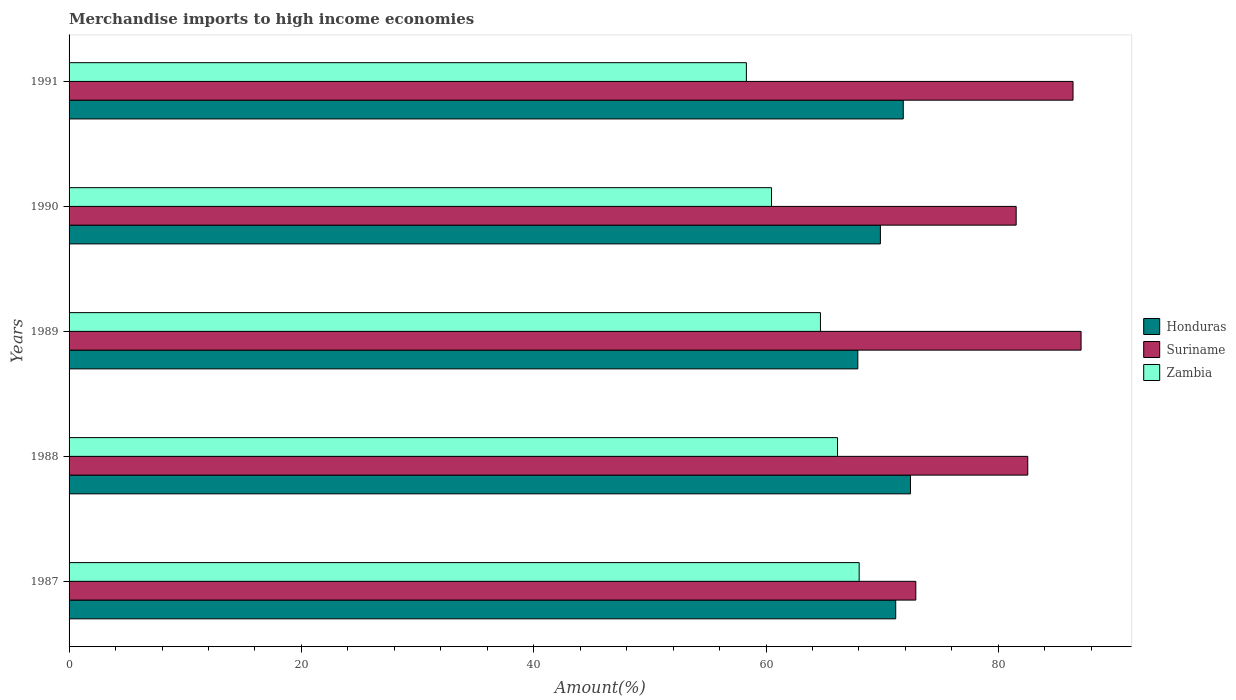How many groups of bars are there?
Keep it short and to the point. 5. How many bars are there on the 2nd tick from the bottom?
Provide a short and direct response. 3. In how many cases, is the number of bars for a given year not equal to the number of legend labels?
Your answer should be compact. 0. What is the percentage of amount earned from merchandise imports in Suriname in 1987?
Your answer should be very brief. 72.89. Across all years, what is the maximum percentage of amount earned from merchandise imports in Suriname?
Ensure brevity in your answer.  87.12. Across all years, what is the minimum percentage of amount earned from merchandise imports in Zambia?
Ensure brevity in your answer.  58.31. What is the total percentage of amount earned from merchandise imports in Honduras in the graph?
Provide a short and direct response. 353.15. What is the difference between the percentage of amount earned from merchandise imports in Zambia in 1989 and that in 1990?
Offer a very short reply. 4.21. What is the difference between the percentage of amount earned from merchandise imports in Honduras in 1988 and the percentage of amount earned from merchandise imports in Suriname in 1989?
Your answer should be very brief. -14.69. What is the average percentage of amount earned from merchandise imports in Honduras per year?
Your answer should be compact. 70.63. In the year 1988, what is the difference between the percentage of amount earned from merchandise imports in Zambia and percentage of amount earned from merchandise imports in Suriname?
Ensure brevity in your answer.  -16.38. What is the ratio of the percentage of amount earned from merchandise imports in Honduras in 1987 to that in 1990?
Keep it short and to the point. 1.02. What is the difference between the highest and the second highest percentage of amount earned from merchandise imports in Suriname?
Provide a succinct answer. 0.69. What is the difference between the highest and the lowest percentage of amount earned from merchandise imports in Zambia?
Provide a short and direct response. 9.71. In how many years, is the percentage of amount earned from merchandise imports in Honduras greater than the average percentage of amount earned from merchandise imports in Honduras taken over all years?
Keep it short and to the point. 3. Is the sum of the percentage of amount earned from merchandise imports in Honduras in 1988 and 1989 greater than the maximum percentage of amount earned from merchandise imports in Zambia across all years?
Offer a terse response. Yes. What does the 3rd bar from the top in 1989 represents?
Offer a very short reply. Honduras. What does the 1st bar from the bottom in 1988 represents?
Your answer should be very brief. Honduras. How many bars are there?
Provide a short and direct response. 15. What is the difference between two consecutive major ticks on the X-axis?
Keep it short and to the point. 20. Does the graph contain grids?
Give a very brief answer. No. Where does the legend appear in the graph?
Offer a terse response. Center right. What is the title of the graph?
Give a very brief answer. Merchandise imports to high income economies. What is the label or title of the X-axis?
Your response must be concise. Amount(%). What is the label or title of the Y-axis?
Give a very brief answer. Years. What is the Amount(%) of Honduras in 1987?
Offer a very short reply. 71.16. What is the Amount(%) of Suriname in 1987?
Your response must be concise. 72.89. What is the Amount(%) of Zambia in 1987?
Provide a succinct answer. 68.02. What is the Amount(%) of Honduras in 1988?
Keep it short and to the point. 72.43. What is the Amount(%) in Suriname in 1988?
Your answer should be compact. 82.53. What is the Amount(%) of Zambia in 1988?
Make the answer very short. 66.15. What is the Amount(%) of Honduras in 1989?
Your answer should be compact. 67.9. What is the Amount(%) of Suriname in 1989?
Your response must be concise. 87.12. What is the Amount(%) in Zambia in 1989?
Ensure brevity in your answer.  64.68. What is the Amount(%) in Honduras in 1990?
Make the answer very short. 69.84. What is the Amount(%) in Suriname in 1990?
Make the answer very short. 81.53. What is the Amount(%) of Zambia in 1990?
Keep it short and to the point. 60.47. What is the Amount(%) of Honduras in 1991?
Make the answer very short. 71.81. What is the Amount(%) of Suriname in 1991?
Ensure brevity in your answer.  86.43. What is the Amount(%) in Zambia in 1991?
Offer a terse response. 58.31. Across all years, what is the maximum Amount(%) of Honduras?
Make the answer very short. 72.43. Across all years, what is the maximum Amount(%) of Suriname?
Offer a very short reply. 87.12. Across all years, what is the maximum Amount(%) of Zambia?
Your answer should be compact. 68.02. Across all years, what is the minimum Amount(%) in Honduras?
Offer a very short reply. 67.9. Across all years, what is the minimum Amount(%) in Suriname?
Your answer should be very brief. 72.89. Across all years, what is the minimum Amount(%) in Zambia?
Your answer should be compact. 58.31. What is the total Amount(%) in Honduras in the graph?
Give a very brief answer. 353.15. What is the total Amount(%) of Suriname in the graph?
Offer a very short reply. 410.5. What is the total Amount(%) of Zambia in the graph?
Your answer should be very brief. 317.63. What is the difference between the Amount(%) of Honduras in 1987 and that in 1988?
Your answer should be compact. -1.27. What is the difference between the Amount(%) of Suriname in 1987 and that in 1988?
Keep it short and to the point. -9.64. What is the difference between the Amount(%) of Zambia in 1987 and that in 1988?
Make the answer very short. 1.86. What is the difference between the Amount(%) of Honduras in 1987 and that in 1989?
Give a very brief answer. 3.26. What is the difference between the Amount(%) in Suriname in 1987 and that in 1989?
Your response must be concise. -14.23. What is the difference between the Amount(%) of Zambia in 1987 and that in 1989?
Provide a succinct answer. 3.33. What is the difference between the Amount(%) of Honduras in 1987 and that in 1990?
Keep it short and to the point. 1.32. What is the difference between the Amount(%) in Suriname in 1987 and that in 1990?
Keep it short and to the point. -8.64. What is the difference between the Amount(%) in Zambia in 1987 and that in 1990?
Your answer should be compact. 7.54. What is the difference between the Amount(%) of Honduras in 1987 and that in 1991?
Give a very brief answer. -0.65. What is the difference between the Amount(%) in Suriname in 1987 and that in 1991?
Give a very brief answer. -13.53. What is the difference between the Amount(%) in Zambia in 1987 and that in 1991?
Ensure brevity in your answer.  9.71. What is the difference between the Amount(%) of Honduras in 1988 and that in 1989?
Provide a short and direct response. 4.53. What is the difference between the Amount(%) of Suriname in 1988 and that in 1989?
Keep it short and to the point. -4.59. What is the difference between the Amount(%) of Zambia in 1988 and that in 1989?
Give a very brief answer. 1.47. What is the difference between the Amount(%) in Honduras in 1988 and that in 1990?
Your answer should be very brief. 2.59. What is the difference between the Amount(%) in Zambia in 1988 and that in 1990?
Ensure brevity in your answer.  5.68. What is the difference between the Amount(%) of Honduras in 1988 and that in 1991?
Your answer should be compact. 0.62. What is the difference between the Amount(%) in Suriname in 1988 and that in 1991?
Your response must be concise. -3.9. What is the difference between the Amount(%) in Zambia in 1988 and that in 1991?
Make the answer very short. 7.85. What is the difference between the Amount(%) in Honduras in 1989 and that in 1990?
Your answer should be very brief. -1.94. What is the difference between the Amount(%) of Suriname in 1989 and that in 1990?
Offer a terse response. 5.59. What is the difference between the Amount(%) in Zambia in 1989 and that in 1990?
Give a very brief answer. 4.21. What is the difference between the Amount(%) of Honduras in 1989 and that in 1991?
Make the answer very short. -3.91. What is the difference between the Amount(%) in Suriname in 1989 and that in 1991?
Keep it short and to the point. 0.69. What is the difference between the Amount(%) of Zambia in 1989 and that in 1991?
Ensure brevity in your answer.  6.38. What is the difference between the Amount(%) of Honduras in 1990 and that in 1991?
Make the answer very short. -1.97. What is the difference between the Amount(%) of Suriname in 1990 and that in 1991?
Offer a terse response. -4.9. What is the difference between the Amount(%) in Zambia in 1990 and that in 1991?
Your answer should be very brief. 2.16. What is the difference between the Amount(%) of Honduras in 1987 and the Amount(%) of Suriname in 1988?
Ensure brevity in your answer.  -11.37. What is the difference between the Amount(%) in Honduras in 1987 and the Amount(%) in Zambia in 1988?
Keep it short and to the point. 5.01. What is the difference between the Amount(%) of Suriname in 1987 and the Amount(%) of Zambia in 1988?
Give a very brief answer. 6.74. What is the difference between the Amount(%) in Honduras in 1987 and the Amount(%) in Suriname in 1989?
Offer a terse response. -15.96. What is the difference between the Amount(%) in Honduras in 1987 and the Amount(%) in Zambia in 1989?
Keep it short and to the point. 6.48. What is the difference between the Amount(%) of Suriname in 1987 and the Amount(%) of Zambia in 1989?
Offer a terse response. 8.21. What is the difference between the Amount(%) of Honduras in 1987 and the Amount(%) of Suriname in 1990?
Your answer should be very brief. -10.37. What is the difference between the Amount(%) of Honduras in 1987 and the Amount(%) of Zambia in 1990?
Your response must be concise. 10.69. What is the difference between the Amount(%) of Suriname in 1987 and the Amount(%) of Zambia in 1990?
Your answer should be compact. 12.42. What is the difference between the Amount(%) of Honduras in 1987 and the Amount(%) of Suriname in 1991?
Give a very brief answer. -15.26. What is the difference between the Amount(%) in Honduras in 1987 and the Amount(%) in Zambia in 1991?
Make the answer very short. 12.86. What is the difference between the Amount(%) in Suriname in 1987 and the Amount(%) in Zambia in 1991?
Keep it short and to the point. 14.58. What is the difference between the Amount(%) of Honduras in 1988 and the Amount(%) of Suriname in 1989?
Provide a succinct answer. -14.69. What is the difference between the Amount(%) of Honduras in 1988 and the Amount(%) of Zambia in 1989?
Give a very brief answer. 7.75. What is the difference between the Amount(%) of Suriname in 1988 and the Amount(%) of Zambia in 1989?
Provide a succinct answer. 17.85. What is the difference between the Amount(%) in Honduras in 1988 and the Amount(%) in Suriname in 1990?
Your answer should be compact. -9.1. What is the difference between the Amount(%) in Honduras in 1988 and the Amount(%) in Zambia in 1990?
Ensure brevity in your answer.  11.96. What is the difference between the Amount(%) in Suriname in 1988 and the Amount(%) in Zambia in 1990?
Provide a succinct answer. 22.06. What is the difference between the Amount(%) in Honduras in 1988 and the Amount(%) in Suriname in 1991?
Make the answer very short. -13.99. What is the difference between the Amount(%) of Honduras in 1988 and the Amount(%) of Zambia in 1991?
Offer a terse response. 14.12. What is the difference between the Amount(%) of Suriname in 1988 and the Amount(%) of Zambia in 1991?
Give a very brief answer. 24.22. What is the difference between the Amount(%) of Honduras in 1989 and the Amount(%) of Suriname in 1990?
Offer a very short reply. -13.63. What is the difference between the Amount(%) of Honduras in 1989 and the Amount(%) of Zambia in 1990?
Offer a very short reply. 7.43. What is the difference between the Amount(%) in Suriname in 1989 and the Amount(%) in Zambia in 1990?
Make the answer very short. 26.65. What is the difference between the Amount(%) of Honduras in 1989 and the Amount(%) of Suriname in 1991?
Provide a short and direct response. -18.53. What is the difference between the Amount(%) of Honduras in 1989 and the Amount(%) of Zambia in 1991?
Offer a very short reply. 9.59. What is the difference between the Amount(%) in Suriname in 1989 and the Amount(%) in Zambia in 1991?
Your response must be concise. 28.81. What is the difference between the Amount(%) in Honduras in 1990 and the Amount(%) in Suriname in 1991?
Make the answer very short. -16.58. What is the difference between the Amount(%) of Honduras in 1990 and the Amount(%) of Zambia in 1991?
Your response must be concise. 11.54. What is the difference between the Amount(%) in Suriname in 1990 and the Amount(%) in Zambia in 1991?
Offer a terse response. 23.22. What is the average Amount(%) in Honduras per year?
Provide a short and direct response. 70.63. What is the average Amount(%) of Suriname per year?
Your answer should be very brief. 82.1. What is the average Amount(%) of Zambia per year?
Provide a short and direct response. 63.53. In the year 1987, what is the difference between the Amount(%) in Honduras and Amount(%) in Suriname?
Make the answer very short. -1.73. In the year 1987, what is the difference between the Amount(%) of Honduras and Amount(%) of Zambia?
Your response must be concise. 3.15. In the year 1987, what is the difference between the Amount(%) in Suriname and Amount(%) in Zambia?
Provide a succinct answer. 4.88. In the year 1988, what is the difference between the Amount(%) in Honduras and Amount(%) in Suriname?
Offer a terse response. -10.1. In the year 1988, what is the difference between the Amount(%) in Honduras and Amount(%) in Zambia?
Ensure brevity in your answer.  6.28. In the year 1988, what is the difference between the Amount(%) in Suriname and Amount(%) in Zambia?
Your answer should be compact. 16.38. In the year 1989, what is the difference between the Amount(%) of Honduras and Amount(%) of Suriname?
Offer a very short reply. -19.22. In the year 1989, what is the difference between the Amount(%) of Honduras and Amount(%) of Zambia?
Ensure brevity in your answer.  3.22. In the year 1989, what is the difference between the Amount(%) of Suriname and Amount(%) of Zambia?
Your answer should be compact. 22.44. In the year 1990, what is the difference between the Amount(%) of Honduras and Amount(%) of Suriname?
Make the answer very short. -11.69. In the year 1990, what is the difference between the Amount(%) of Honduras and Amount(%) of Zambia?
Keep it short and to the point. 9.37. In the year 1990, what is the difference between the Amount(%) in Suriname and Amount(%) in Zambia?
Give a very brief answer. 21.06. In the year 1991, what is the difference between the Amount(%) in Honduras and Amount(%) in Suriname?
Offer a very short reply. -14.61. In the year 1991, what is the difference between the Amount(%) in Honduras and Amount(%) in Zambia?
Offer a terse response. 13.5. In the year 1991, what is the difference between the Amount(%) in Suriname and Amount(%) in Zambia?
Make the answer very short. 28.12. What is the ratio of the Amount(%) of Honduras in 1987 to that in 1988?
Make the answer very short. 0.98. What is the ratio of the Amount(%) of Suriname in 1987 to that in 1988?
Offer a terse response. 0.88. What is the ratio of the Amount(%) of Zambia in 1987 to that in 1988?
Your answer should be compact. 1.03. What is the ratio of the Amount(%) of Honduras in 1987 to that in 1989?
Your answer should be compact. 1.05. What is the ratio of the Amount(%) of Suriname in 1987 to that in 1989?
Provide a succinct answer. 0.84. What is the ratio of the Amount(%) in Zambia in 1987 to that in 1989?
Provide a succinct answer. 1.05. What is the ratio of the Amount(%) in Honduras in 1987 to that in 1990?
Your response must be concise. 1.02. What is the ratio of the Amount(%) in Suriname in 1987 to that in 1990?
Offer a terse response. 0.89. What is the ratio of the Amount(%) in Zambia in 1987 to that in 1990?
Ensure brevity in your answer.  1.12. What is the ratio of the Amount(%) of Suriname in 1987 to that in 1991?
Offer a very short reply. 0.84. What is the ratio of the Amount(%) of Zambia in 1987 to that in 1991?
Your response must be concise. 1.17. What is the ratio of the Amount(%) of Honduras in 1988 to that in 1989?
Your response must be concise. 1.07. What is the ratio of the Amount(%) in Suriname in 1988 to that in 1989?
Your answer should be very brief. 0.95. What is the ratio of the Amount(%) in Zambia in 1988 to that in 1989?
Offer a terse response. 1.02. What is the ratio of the Amount(%) of Honduras in 1988 to that in 1990?
Provide a short and direct response. 1.04. What is the ratio of the Amount(%) of Suriname in 1988 to that in 1990?
Ensure brevity in your answer.  1.01. What is the ratio of the Amount(%) of Zambia in 1988 to that in 1990?
Your response must be concise. 1.09. What is the ratio of the Amount(%) of Honduras in 1988 to that in 1991?
Offer a very short reply. 1.01. What is the ratio of the Amount(%) of Suriname in 1988 to that in 1991?
Give a very brief answer. 0.95. What is the ratio of the Amount(%) in Zambia in 1988 to that in 1991?
Your answer should be compact. 1.13. What is the ratio of the Amount(%) of Honduras in 1989 to that in 1990?
Your answer should be very brief. 0.97. What is the ratio of the Amount(%) in Suriname in 1989 to that in 1990?
Ensure brevity in your answer.  1.07. What is the ratio of the Amount(%) of Zambia in 1989 to that in 1990?
Provide a succinct answer. 1.07. What is the ratio of the Amount(%) of Honduras in 1989 to that in 1991?
Provide a succinct answer. 0.95. What is the ratio of the Amount(%) in Suriname in 1989 to that in 1991?
Offer a very short reply. 1.01. What is the ratio of the Amount(%) in Zambia in 1989 to that in 1991?
Give a very brief answer. 1.11. What is the ratio of the Amount(%) in Honduras in 1990 to that in 1991?
Offer a terse response. 0.97. What is the ratio of the Amount(%) of Suriname in 1990 to that in 1991?
Your answer should be very brief. 0.94. What is the ratio of the Amount(%) in Zambia in 1990 to that in 1991?
Provide a short and direct response. 1.04. What is the difference between the highest and the second highest Amount(%) of Honduras?
Ensure brevity in your answer.  0.62. What is the difference between the highest and the second highest Amount(%) of Suriname?
Make the answer very short. 0.69. What is the difference between the highest and the second highest Amount(%) of Zambia?
Provide a succinct answer. 1.86. What is the difference between the highest and the lowest Amount(%) of Honduras?
Your answer should be compact. 4.53. What is the difference between the highest and the lowest Amount(%) in Suriname?
Offer a very short reply. 14.23. What is the difference between the highest and the lowest Amount(%) of Zambia?
Ensure brevity in your answer.  9.71. 